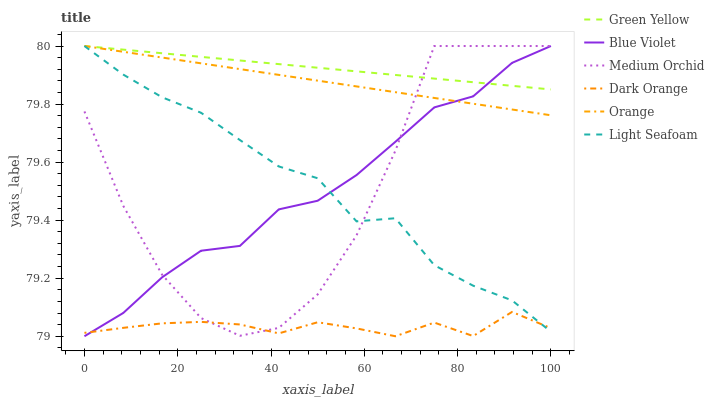Does Light Seafoam have the minimum area under the curve?
Answer yes or no. No. Does Light Seafoam have the maximum area under the curve?
Answer yes or no. No. Is Light Seafoam the smoothest?
Answer yes or no. No. Is Light Seafoam the roughest?
Answer yes or no. No. Does Light Seafoam have the lowest value?
Answer yes or no. No. Is Dark Orange less than Orange?
Answer yes or no. Yes. Is Orange greater than Dark Orange?
Answer yes or no. Yes. Does Dark Orange intersect Orange?
Answer yes or no. No. 